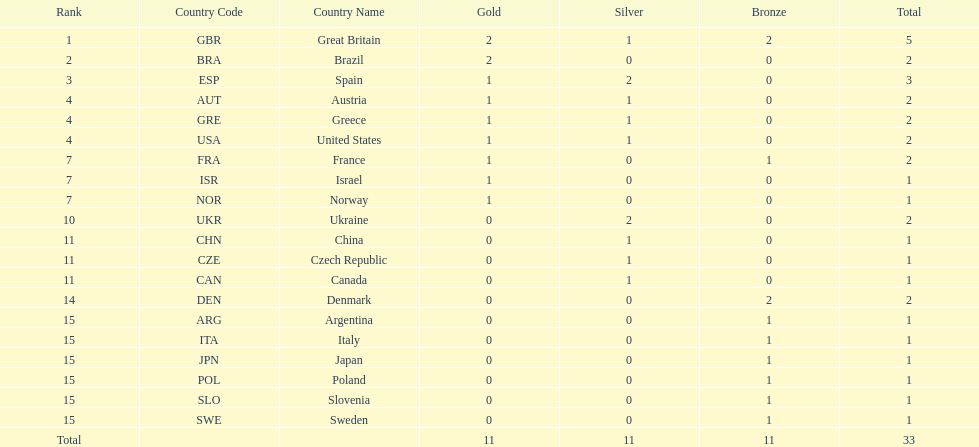Which country won the most medals total? Great Britain (GBR). 